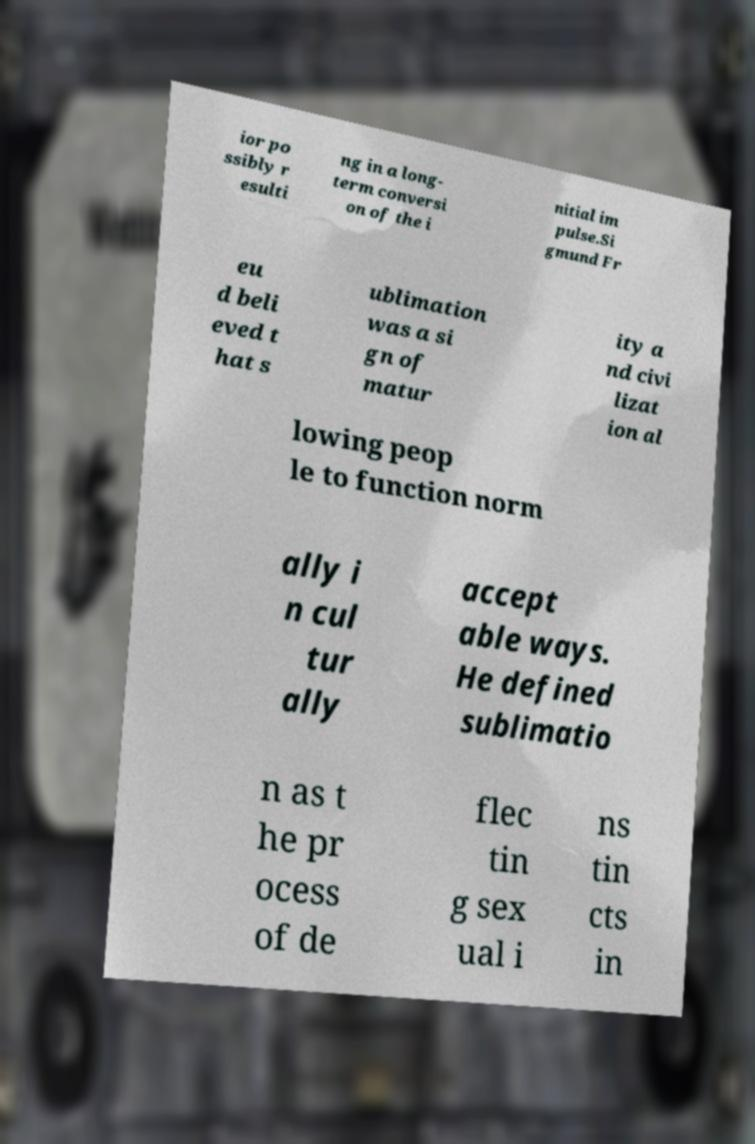Can you accurately transcribe the text from the provided image for me? ior po ssibly r esulti ng in a long- term conversi on of the i nitial im pulse.Si gmund Fr eu d beli eved t hat s ublimation was a si gn of matur ity a nd civi lizat ion al lowing peop le to function norm ally i n cul tur ally accept able ways. He defined sublimatio n as t he pr ocess of de flec tin g sex ual i ns tin cts in 